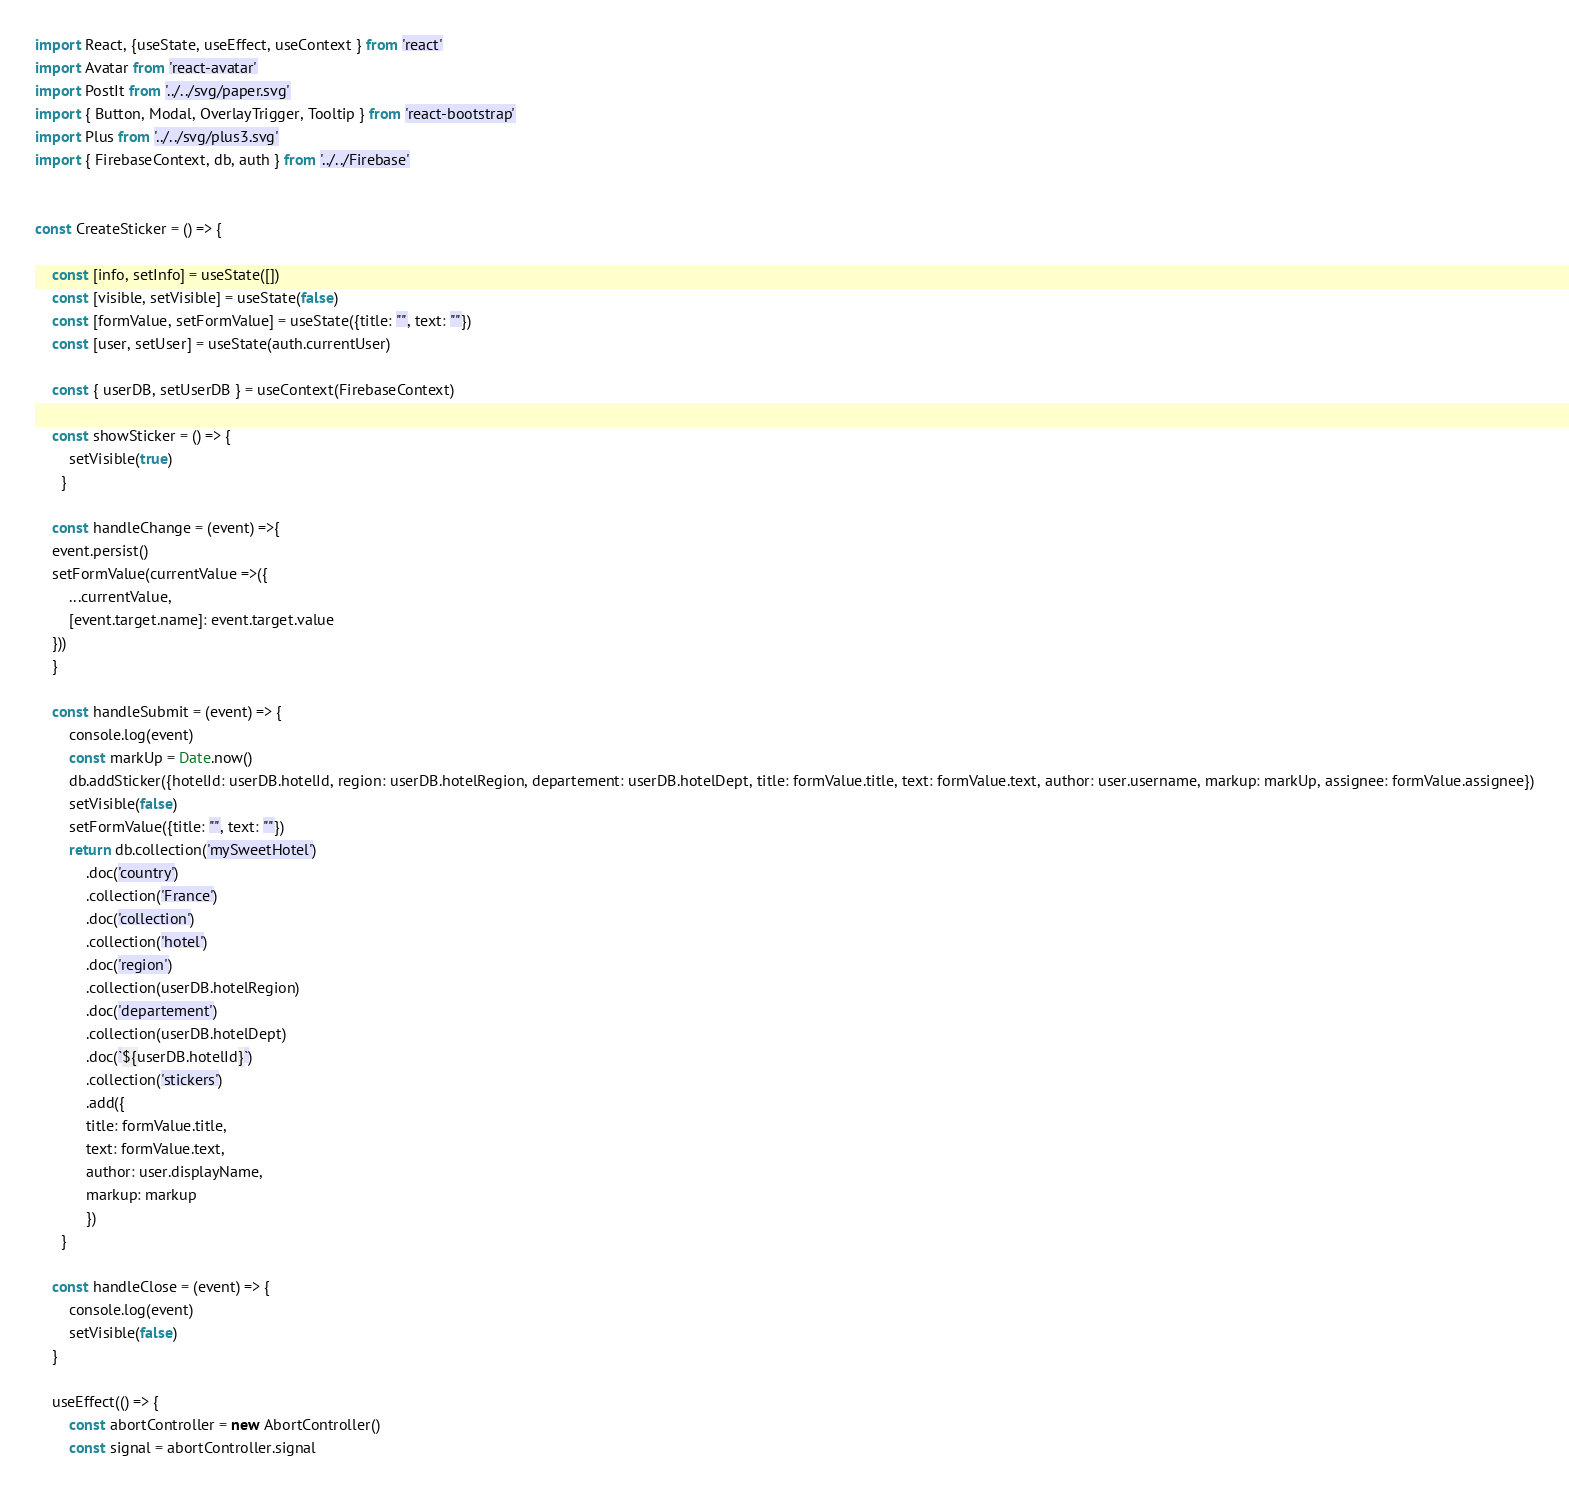<code> <loc_0><loc_0><loc_500><loc_500><_JavaScript_>import React, {useState, useEffect, useContext } from 'react'
import Avatar from 'react-avatar'
import PostIt from '../../svg/paper.svg'
import { Button, Modal, OverlayTrigger, Tooltip } from 'react-bootstrap'
import Plus from '../../svg/plus3.svg'
import { FirebaseContext, db, auth } from '../../Firebase'


const CreateSticker = () => {

    const [info, setInfo] = useState([])
    const [visible, setVisible] = useState(false)
    const [formValue, setFormValue] = useState({title: "", text: ""})
    const [user, setUser] = useState(auth.currentUser)

    const { userDB, setUserDB } = useContext(FirebaseContext)

    const showSticker = () => {
        setVisible(true)
      }

    const handleChange = (event) =>{
    event.persist()
    setFormValue(currentValue =>({
        ...currentValue,
        [event.target.name]: event.target.value
    }))
    }
    
    const handleSubmit = (event) => {
        console.log(event)
        const markUp = Date.now()
        db.addSticker({hotelId: userDB.hotelId, region: userDB.hotelRegion, departement: userDB.hotelDept, title: formValue.title, text: formValue.text, author: user.username, markup: markUp, assignee: formValue.assignee})
        setVisible(false)
        setFormValue({title: "", text: ""})
        return db.collection('mySweetHotel')
            .doc('country')
            .collection('France')
            .doc('collection')
            .collection('hotel')
            .doc('region')
            .collection(userDB.hotelRegion)
            .doc('departement')
            .collection(userDB.hotelDept)
            .doc(`${userDB.hotelId}`)
            .collection('stickers')
            .add({
            title: formValue.title,
            text: formValue.text,
            author: user.displayName,
            markup: markup
            })
      }
    
    const handleClose = (event) => {
        console.log(event)
        setVisible(false)
    }

    useEffect(() => {
        const abortController = new AbortController()
        const signal = abortController.signal</code> 